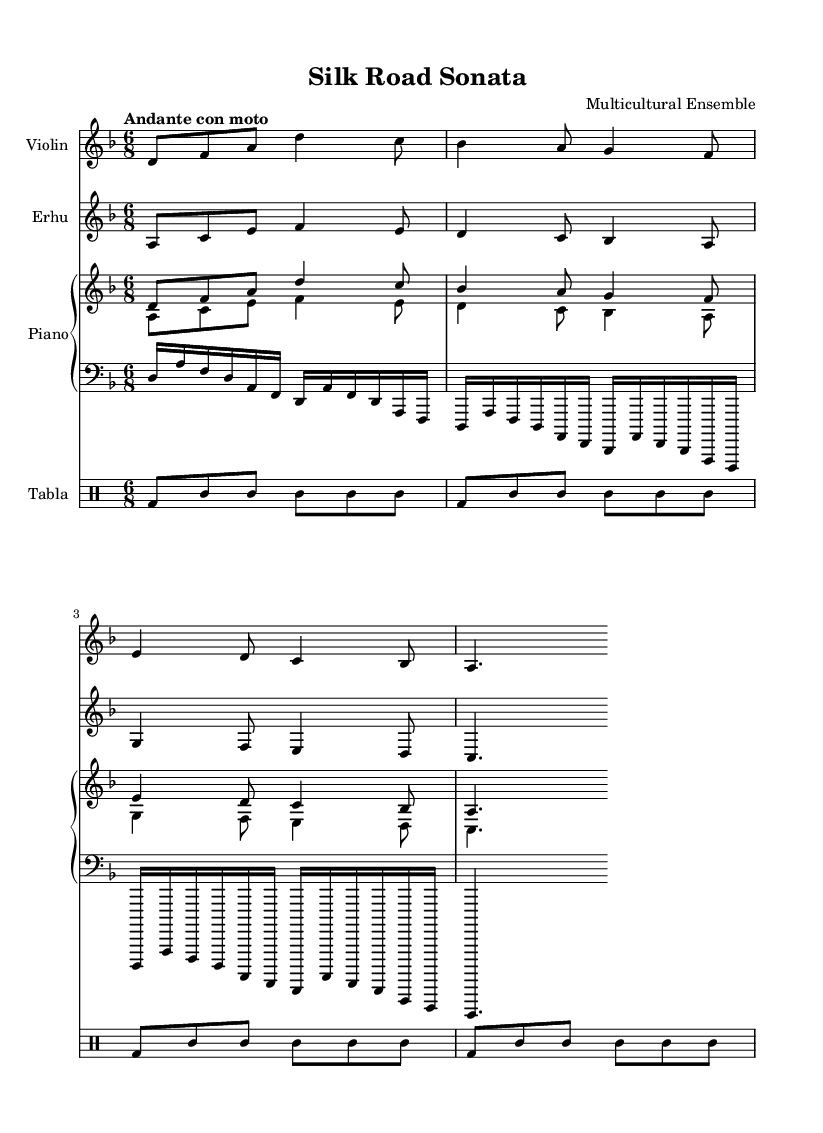What is the key signature of this composition? The key signature is D minor, which has one flat (B flat). This can be determined by looking at the key signature indicated at the beginning of the music.
Answer: D minor What is the time signature of this piece? The time signature is six-eight. This is seen at the beginning of the score, where the time signature is notated. It indicates that there are six beats in each measure, and the eighth note gets one beat.
Answer: 6/8 What is the tempo marking for the piece? The tempo marking is "Andante con moto." This is indicated in the header above the musical staff, suggesting a moderate pace with a sense of motion.
Answer: Andante con moto How many instruments are featured in the score? There are four instruments featured in the score: Violin, Erhu, Piano, and Tabla. By examining the different staves, we can count the distinct instruments present in the score.
Answer: Four What is the rhythmic pattern used in the Tabla part? The rhythmic pattern in the Tabla part consists mainly of the bda stroke followed by ssh strokes. This pattern is repeated throughout the piece, with close inspection of the drum staff revealing the notational rhythm.
Answer: bda and ssh How does the piano right hand relate to the violin's melody? The piano right hand plays a melody that closely mirrors the violin's melody, often matching the notes in the same rhythmic structure. To analyze this, you can compare the two staves, noticing the similar pitches played simultaneous to the violin part.
Answer: It mirrors the violin melody What cultural elements are represented in this composition? The composition features elements from multicultural traditions, particularly the inclusion of the Erhu, a traditional Chinese instrument, alongside Western instruments like the Violin and Piano. This blend showcases diversity in instrumentation.
Answer: Multicultural traditions 